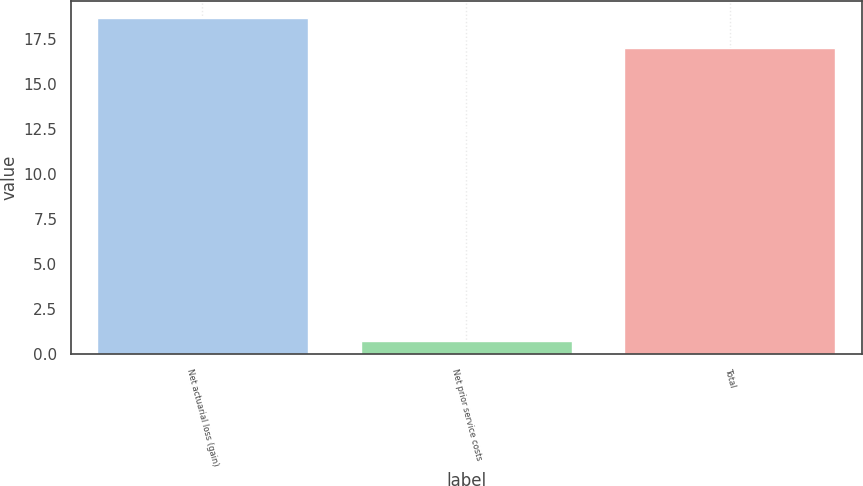<chart> <loc_0><loc_0><loc_500><loc_500><bar_chart><fcel>Net actuarial loss (gain)<fcel>Net prior service costs<fcel>Total<nl><fcel>18.7<fcel>0.7<fcel>17<nl></chart> 